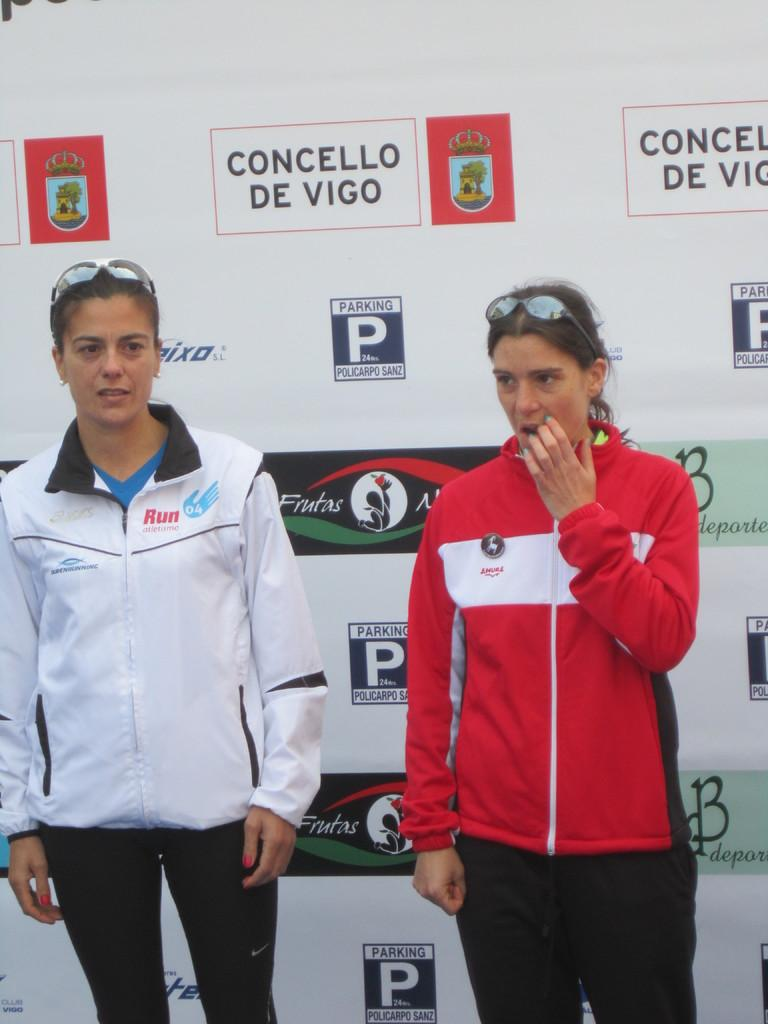<image>
Provide a brief description of the given image. Two women stand in front of a "Concello de vigo" poster. 